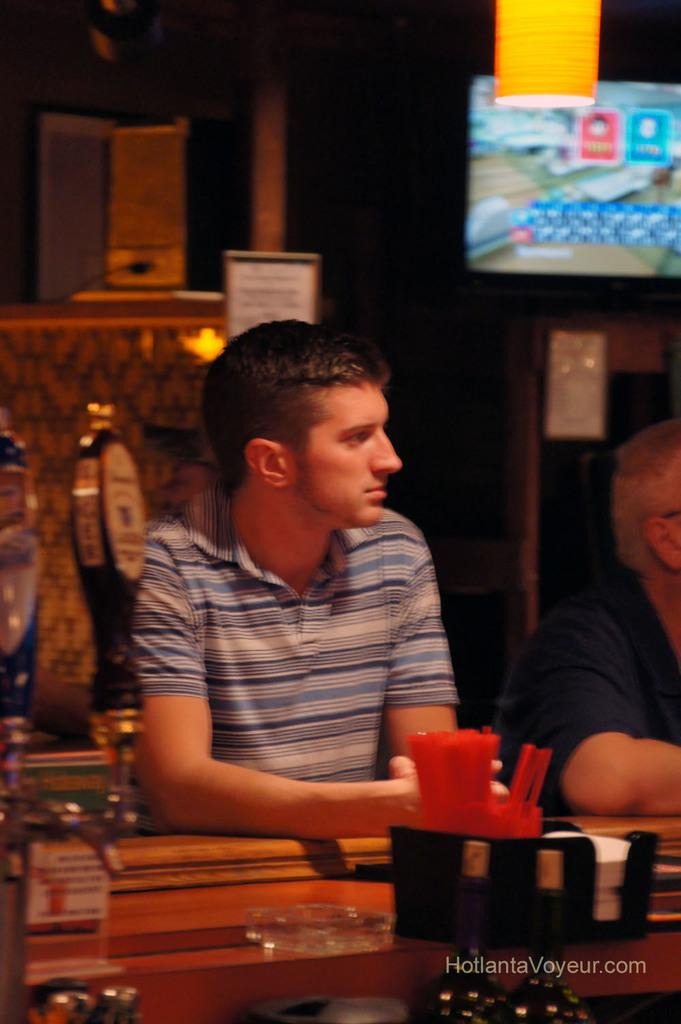What is the position of the person in the image? There is a person sitting in front of a table in the image. What can be seen on the table? There are objects on the table in the image. How many people are sitting at the table? There are two people sitting at the table in the image, one beside the other. What type of coil is being used by the person sitting beside the first person? There is no coil present in the image. What are the two people talking about in the image? The image does not provide any information about the conversation between the two people. 